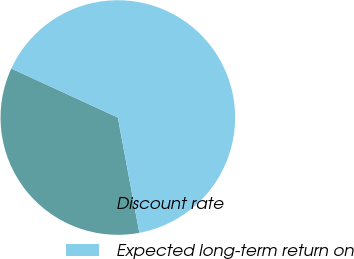<chart> <loc_0><loc_0><loc_500><loc_500><pie_chart><fcel>Discount rate<fcel>Expected long-term return on<nl><fcel>34.8%<fcel>65.2%<nl></chart> 